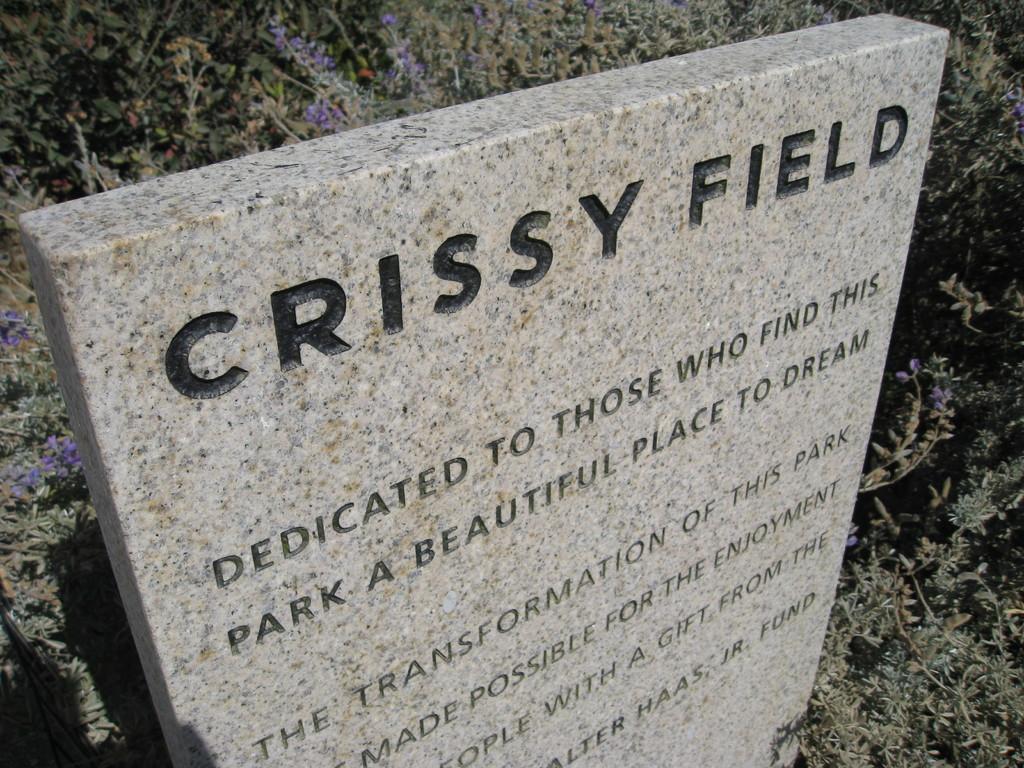How would you summarize this image in a sentence or two? In this picture, we see a headstone for a commemorative plaque with some text written on it. In the background, we see the plants which have flowers and these flowers are in violet color. 